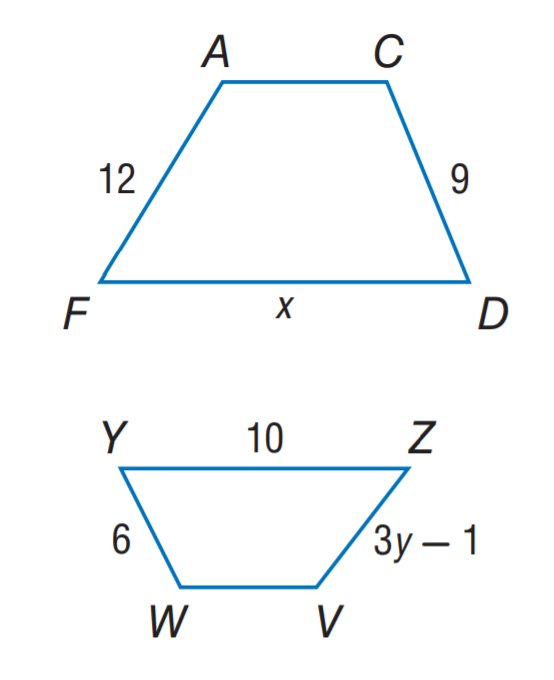Answer the mathemtical geometry problem and directly provide the correct option letter.
Question: A C D F \sim V W Y Z. Find x.
Choices: A: 9 B: 10 C: 12 D: 15 D 